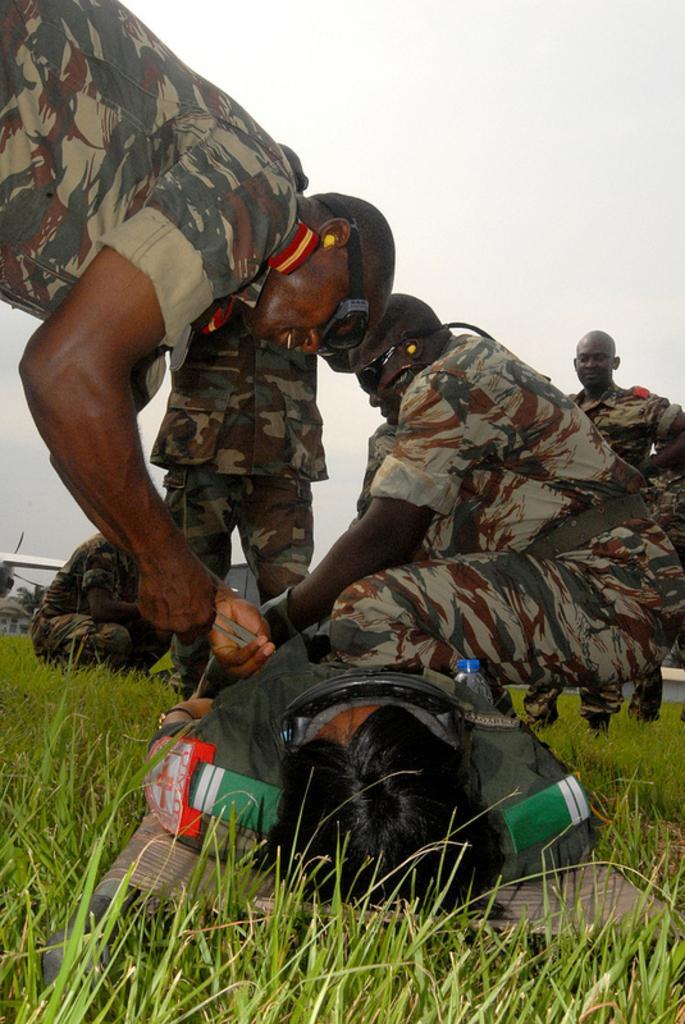Could you give a brief overview of what you see in this image? In this image there are many people wearing uniform. Here a person is lying on the ground. On the ground there are grasses. The sky is clear. Here three persons are wearing eye protection glasses. 